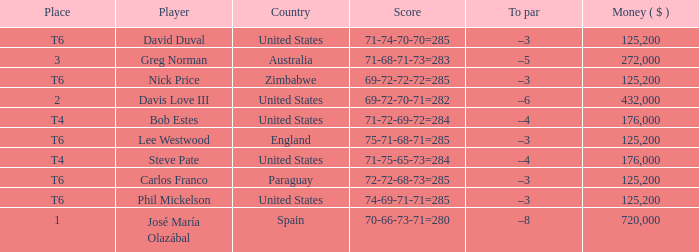Which Place has a To par of –8? 1.0. 